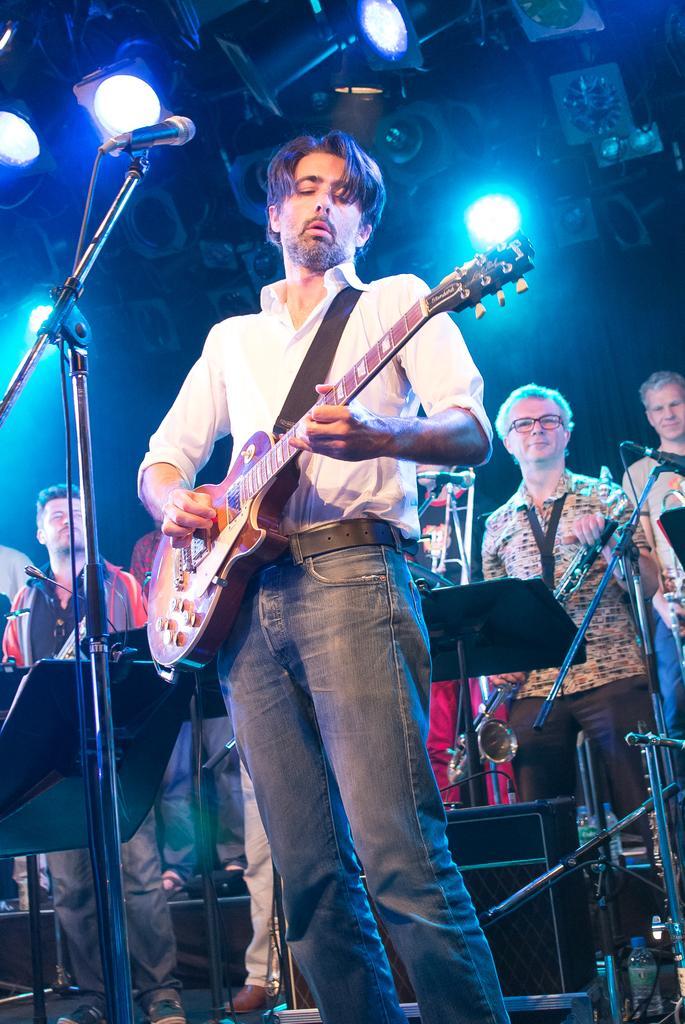Could you give a brief overview of what you see in this image? As we can see in the image, there are few people standing and the man who is standing and the man who is standing here is holding guitar. In front of him there is a mic. 